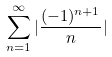Convert formula to latex. <formula><loc_0><loc_0><loc_500><loc_500>\sum _ { n = 1 } ^ { \infty } | \frac { ( - 1 ) ^ { n + 1 } } { n } |</formula> 